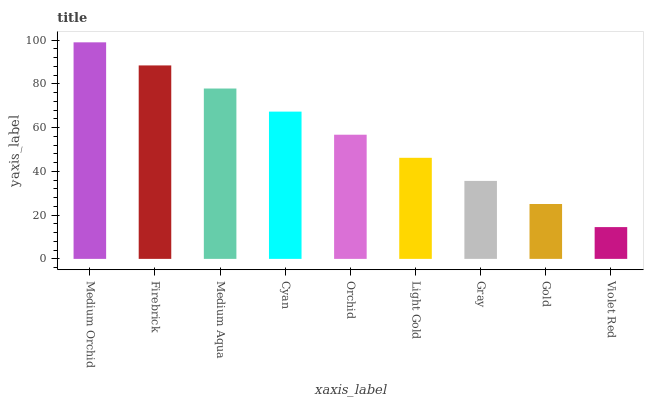Is Violet Red the minimum?
Answer yes or no. Yes. Is Medium Orchid the maximum?
Answer yes or no. Yes. Is Firebrick the minimum?
Answer yes or no. No. Is Firebrick the maximum?
Answer yes or no. No. Is Medium Orchid greater than Firebrick?
Answer yes or no. Yes. Is Firebrick less than Medium Orchid?
Answer yes or no. Yes. Is Firebrick greater than Medium Orchid?
Answer yes or no. No. Is Medium Orchid less than Firebrick?
Answer yes or no. No. Is Orchid the high median?
Answer yes or no. Yes. Is Orchid the low median?
Answer yes or no. Yes. Is Medium Orchid the high median?
Answer yes or no. No. Is Cyan the low median?
Answer yes or no. No. 